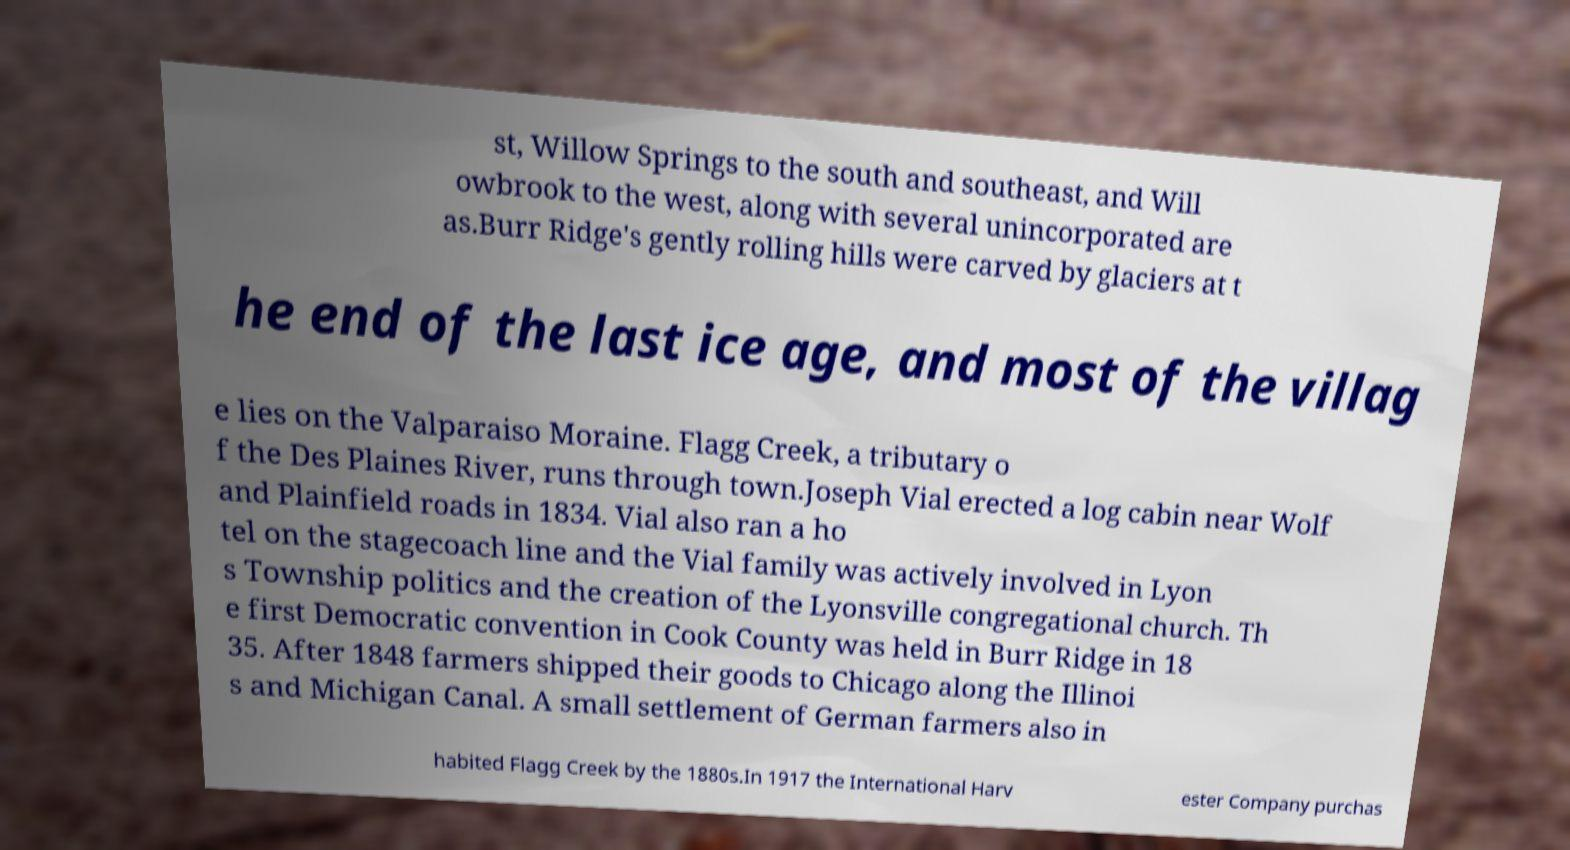Please identify and transcribe the text found in this image. st, Willow Springs to the south and southeast, and Will owbrook to the west, along with several unincorporated are as.Burr Ridge's gently rolling hills were carved by glaciers at t he end of the last ice age, and most of the villag e lies on the Valparaiso Moraine. Flagg Creek, a tributary o f the Des Plaines River, runs through town.Joseph Vial erected a log cabin near Wolf and Plainfield roads in 1834. Vial also ran a ho tel on the stagecoach line and the Vial family was actively involved in Lyon s Township politics and the creation of the Lyonsville congregational church. Th e first Democratic convention in Cook County was held in Burr Ridge in 18 35. After 1848 farmers shipped their goods to Chicago along the Illinoi s and Michigan Canal. A small settlement of German farmers also in habited Flagg Creek by the 1880s.In 1917 the International Harv ester Company purchas 